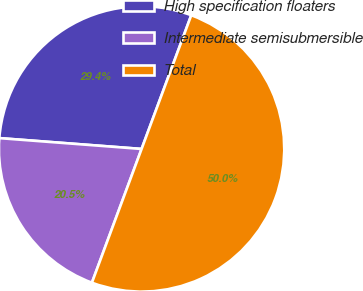Convert chart to OTSL. <chart><loc_0><loc_0><loc_500><loc_500><pie_chart><fcel>High specification floaters<fcel>Intermediate semisubmersible<fcel>Total<nl><fcel>29.45%<fcel>20.55%<fcel>50.0%<nl></chart> 